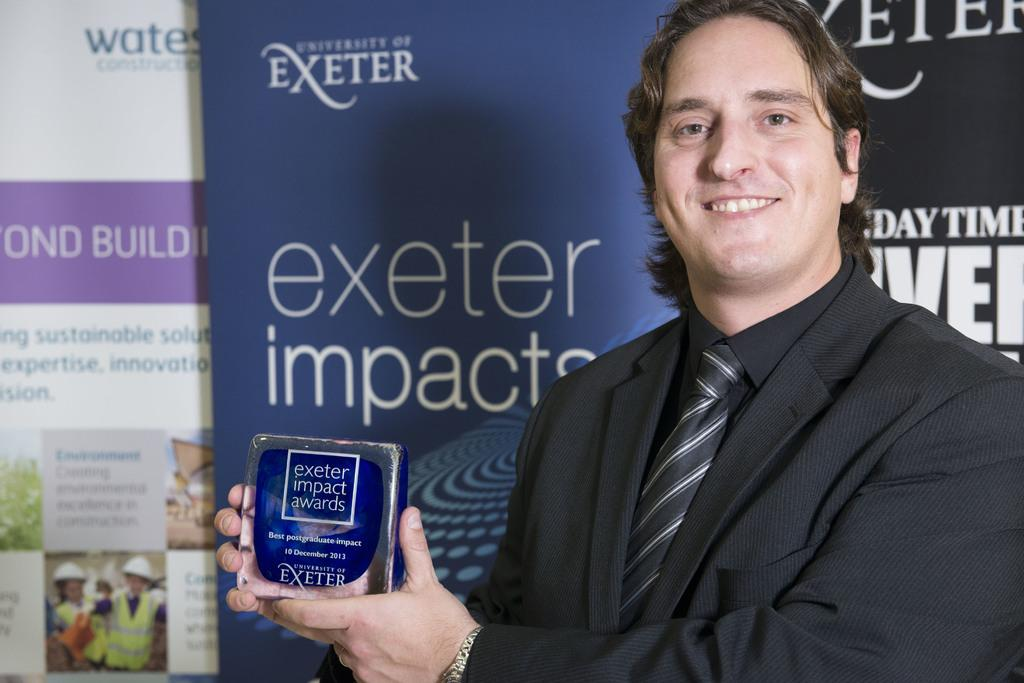What is the main subject in the foreground of the image? There is a person in the foreground of the image. What is the person holding in the image? The person is holding a box. What can be seen in the background of the image? There are boards in the background of the image. What is written or depicted on the boards? There is text on the boards. How many plants are growing on the person in the image? There are no plants visible on the person in the image. What type of rod can be seen in the person's hand in the image? There is no rod present in the person's hand in the image. 